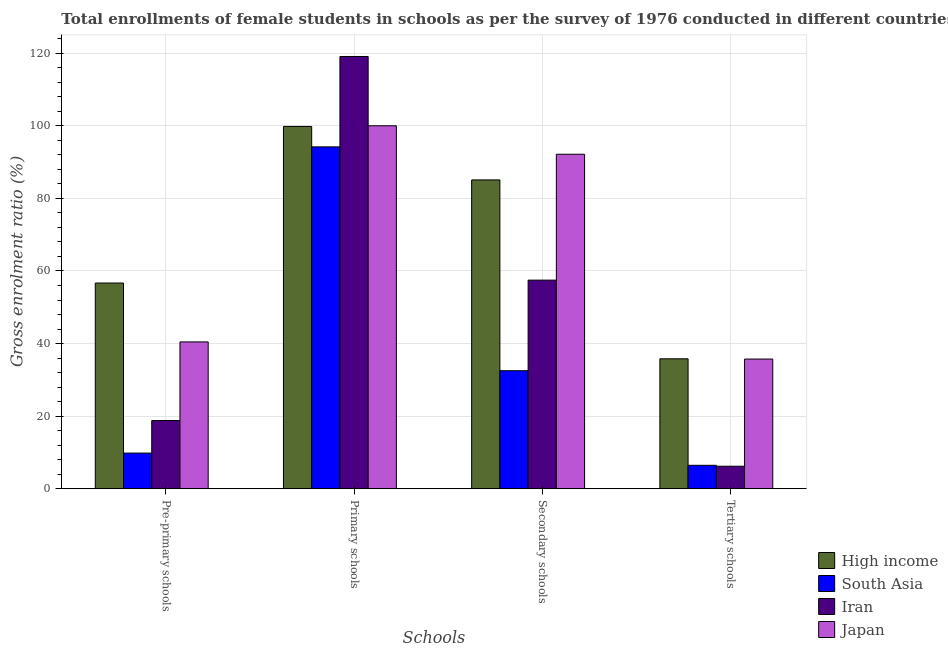Are the number of bars on each tick of the X-axis equal?
Provide a short and direct response. Yes. What is the label of the 2nd group of bars from the left?
Ensure brevity in your answer.  Primary schools. What is the gross enrolment ratio(female) in pre-primary schools in High income?
Keep it short and to the point. 56.68. Across all countries, what is the maximum gross enrolment ratio(female) in pre-primary schools?
Give a very brief answer. 56.68. Across all countries, what is the minimum gross enrolment ratio(female) in pre-primary schools?
Your answer should be compact. 9.81. In which country was the gross enrolment ratio(female) in tertiary schools maximum?
Your answer should be compact. High income. In which country was the gross enrolment ratio(female) in tertiary schools minimum?
Keep it short and to the point. Iran. What is the total gross enrolment ratio(female) in primary schools in the graph?
Make the answer very short. 413.2. What is the difference between the gross enrolment ratio(female) in tertiary schools in High income and that in Japan?
Provide a short and direct response. 0.07. What is the difference between the gross enrolment ratio(female) in primary schools in High income and the gross enrolment ratio(female) in pre-primary schools in Iran?
Provide a short and direct response. 81.07. What is the average gross enrolment ratio(female) in pre-primary schools per country?
Keep it short and to the point. 31.43. What is the difference between the gross enrolment ratio(female) in secondary schools and gross enrolment ratio(female) in tertiary schools in High income?
Ensure brevity in your answer.  49.3. What is the ratio of the gross enrolment ratio(female) in pre-primary schools in South Asia to that in Iran?
Offer a terse response. 0.52. Is the gross enrolment ratio(female) in secondary schools in High income less than that in Japan?
Your response must be concise. Yes. Is the difference between the gross enrolment ratio(female) in pre-primary schools in South Asia and Iran greater than the difference between the gross enrolment ratio(female) in tertiary schools in South Asia and Iran?
Offer a terse response. No. What is the difference between the highest and the second highest gross enrolment ratio(female) in secondary schools?
Your answer should be very brief. 7.07. What is the difference between the highest and the lowest gross enrolment ratio(female) in pre-primary schools?
Ensure brevity in your answer.  46.87. What does the 3rd bar from the right in Secondary schools represents?
Your response must be concise. South Asia. Are all the bars in the graph horizontal?
Offer a terse response. No. What is the difference between two consecutive major ticks on the Y-axis?
Keep it short and to the point. 20. Does the graph contain grids?
Offer a very short reply. Yes. How many legend labels are there?
Offer a terse response. 4. How are the legend labels stacked?
Provide a succinct answer. Vertical. What is the title of the graph?
Offer a very short reply. Total enrollments of female students in schools as per the survey of 1976 conducted in different countries. Does "Tuvalu" appear as one of the legend labels in the graph?
Give a very brief answer. No. What is the label or title of the X-axis?
Offer a terse response. Schools. What is the label or title of the Y-axis?
Your answer should be compact. Gross enrolment ratio (%). What is the Gross enrolment ratio (%) in High income in Pre-primary schools?
Make the answer very short. 56.68. What is the Gross enrolment ratio (%) in South Asia in Pre-primary schools?
Provide a succinct answer. 9.81. What is the Gross enrolment ratio (%) of Iran in Pre-primary schools?
Your answer should be very brief. 18.78. What is the Gross enrolment ratio (%) of Japan in Pre-primary schools?
Offer a terse response. 40.45. What is the Gross enrolment ratio (%) of High income in Primary schools?
Provide a succinct answer. 99.84. What is the Gross enrolment ratio (%) of South Asia in Primary schools?
Provide a short and direct response. 94.21. What is the Gross enrolment ratio (%) in Iran in Primary schools?
Give a very brief answer. 119.12. What is the Gross enrolment ratio (%) of Japan in Primary schools?
Make the answer very short. 100.02. What is the Gross enrolment ratio (%) of High income in Secondary schools?
Ensure brevity in your answer.  85.1. What is the Gross enrolment ratio (%) in South Asia in Secondary schools?
Provide a short and direct response. 32.51. What is the Gross enrolment ratio (%) in Iran in Secondary schools?
Your answer should be compact. 57.48. What is the Gross enrolment ratio (%) of Japan in Secondary schools?
Keep it short and to the point. 92.18. What is the Gross enrolment ratio (%) in High income in Tertiary schools?
Your answer should be compact. 35.8. What is the Gross enrolment ratio (%) of South Asia in Tertiary schools?
Provide a succinct answer. 6.44. What is the Gross enrolment ratio (%) in Iran in Tertiary schools?
Your response must be concise. 6.19. What is the Gross enrolment ratio (%) in Japan in Tertiary schools?
Your answer should be compact. 35.73. Across all Schools, what is the maximum Gross enrolment ratio (%) of High income?
Keep it short and to the point. 99.84. Across all Schools, what is the maximum Gross enrolment ratio (%) of South Asia?
Your answer should be compact. 94.21. Across all Schools, what is the maximum Gross enrolment ratio (%) of Iran?
Your response must be concise. 119.12. Across all Schools, what is the maximum Gross enrolment ratio (%) in Japan?
Offer a very short reply. 100.02. Across all Schools, what is the minimum Gross enrolment ratio (%) in High income?
Provide a succinct answer. 35.8. Across all Schools, what is the minimum Gross enrolment ratio (%) in South Asia?
Your response must be concise. 6.44. Across all Schools, what is the minimum Gross enrolment ratio (%) of Iran?
Your answer should be very brief. 6.19. Across all Schools, what is the minimum Gross enrolment ratio (%) of Japan?
Offer a very short reply. 35.73. What is the total Gross enrolment ratio (%) of High income in the graph?
Your answer should be compact. 277.42. What is the total Gross enrolment ratio (%) in South Asia in the graph?
Make the answer very short. 142.98. What is the total Gross enrolment ratio (%) in Iran in the graph?
Keep it short and to the point. 201.56. What is the total Gross enrolment ratio (%) of Japan in the graph?
Offer a very short reply. 268.38. What is the difference between the Gross enrolment ratio (%) in High income in Pre-primary schools and that in Primary schools?
Give a very brief answer. -43.16. What is the difference between the Gross enrolment ratio (%) in South Asia in Pre-primary schools and that in Primary schools?
Your answer should be compact. -84.4. What is the difference between the Gross enrolment ratio (%) in Iran in Pre-primary schools and that in Primary schools?
Ensure brevity in your answer.  -100.35. What is the difference between the Gross enrolment ratio (%) in Japan in Pre-primary schools and that in Primary schools?
Ensure brevity in your answer.  -59.57. What is the difference between the Gross enrolment ratio (%) in High income in Pre-primary schools and that in Secondary schools?
Provide a short and direct response. -28.42. What is the difference between the Gross enrolment ratio (%) in South Asia in Pre-primary schools and that in Secondary schools?
Provide a succinct answer. -22.7. What is the difference between the Gross enrolment ratio (%) of Iran in Pre-primary schools and that in Secondary schools?
Keep it short and to the point. -38.7. What is the difference between the Gross enrolment ratio (%) of Japan in Pre-primary schools and that in Secondary schools?
Your answer should be very brief. -51.72. What is the difference between the Gross enrolment ratio (%) of High income in Pre-primary schools and that in Tertiary schools?
Your answer should be compact. 20.89. What is the difference between the Gross enrolment ratio (%) in South Asia in Pre-primary schools and that in Tertiary schools?
Offer a very short reply. 3.37. What is the difference between the Gross enrolment ratio (%) in Iran in Pre-primary schools and that in Tertiary schools?
Give a very brief answer. 12.59. What is the difference between the Gross enrolment ratio (%) of Japan in Pre-primary schools and that in Tertiary schools?
Make the answer very short. 4.72. What is the difference between the Gross enrolment ratio (%) in High income in Primary schools and that in Secondary schools?
Offer a very short reply. 14.74. What is the difference between the Gross enrolment ratio (%) in South Asia in Primary schools and that in Secondary schools?
Keep it short and to the point. 61.7. What is the difference between the Gross enrolment ratio (%) of Iran in Primary schools and that in Secondary schools?
Provide a short and direct response. 61.64. What is the difference between the Gross enrolment ratio (%) of Japan in Primary schools and that in Secondary schools?
Provide a short and direct response. 7.85. What is the difference between the Gross enrolment ratio (%) of High income in Primary schools and that in Tertiary schools?
Make the answer very short. 64.05. What is the difference between the Gross enrolment ratio (%) in South Asia in Primary schools and that in Tertiary schools?
Keep it short and to the point. 87.77. What is the difference between the Gross enrolment ratio (%) of Iran in Primary schools and that in Tertiary schools?
Your response must be concise. 112.94. What is the difference between the Gross enrolment ratio (%) of Japan in Primary schools and that in Tertiary schools?
Your answer should be very brief. 64.3. What is the difference between the Gross enrolment ratio (%) in High income in Secondary schools and that in Tertiary schools?
Provide a short and direct response. 49.3. What is the difference between the Gross enrolment ratio (%) in South Asia in Secondary schools and that in Tertiary schools?
Your answer should be very brief. 26.07. What is the difference between the Gross enrolment ratio (%) in Iran in Secondary schools and that in Tertiary schools?
Ensure brevity in your answer.  51.29. What is the difference between the Gross enrolment ratio (%) in Japan in Secondary schools and that in Tertiary schools?
Offer a very short reply. 56.45. What is the difference between the Gross enrolment ratio (%) of High income in Pre-primary schools and the Gross enrolment ratio (%) of South Asia in Primary schools?
Your answer should be very brief. -37.53. What is the difference between the Gross enrolment ratio (%) of High income in Pre-primary schools and the Gross enrolment ratio (%) of Iran in Primary schools?
Your answer should be compact. -62.44. What is the difference between the Gross enrolment ratio (%) of High income in Pre-primary schools and the Gross enrolment ratio (%) of Japan in Primary schools?
Provide a succinct answer. -43.34. What is the difference between the Gross enrolment ratio (%) of South Asia in Pre-primary schools and the Gross enrolment ratio (%) of Iran in Primary schools?
Your answer should be compact. -109.31. What is the difference between the Gross enrolment ratio (%) in South Asia in Pre-primary schools and the Gross enrolment ratio (%) in Japan in Primary schools?
Make the answer very short. -90.21. What is the difference between the Gross enrolment ratio (%) in Iran in Pre-primary schools and the Gross enrolment ratio (%) in Japan in Primary schools?
Your response must be concise. -81.25. What is the difference between the Gross enrolment ratio (%) of High income in Pre-primary schools and the Gross enrolment ratio (%) of South Asia in Secondary schools?
Keep it short and to the point. 24.17. What is the difference between the Gross enrolment ratio (%) in High income in Pre-primary schools and the Gross enrolment ratio (%) in Iran in Secondary schools?
Ensure brevity in your answer.  -0.79. What is the difference between the Gross enrolment ratio (%) in High income in Pre-primary schools and the Gross enrolment ratio (%) in Japan in Secondary schools?
Provide a short and direct response. -35.49. What is the difference between the Gross enrolment ratio (%) of South Asia in Pre-primary schools and the Gross enrolment ratio (%) of Iran in Secondary schools?
Your response must be concise. -47.67. What is the difference between the Gross enrolment ratio (%) in South Asia in Pre-primary schools and the Gross enrolment ratio (%) in Japan in Secondary schools?
Ensure brevity in your answer.  -82.36. What is the difference between the Gross enrolment ratio (%) of Iran in Pre-primary schools and the Gross enrolment ratio (%) of Japan in Secondary schools?
Make the answer very short. -73.4. What is the difference between the Gross enrolment ratio (%) of High income in Pre-primary schools and the Gross enrolment ratio (%) of South Asia in Tertiary schools?
Your response must be concise. 50.24. What is the difference between the Gross enrolment ratio (%) of High income in Pre-primary schools and the Gross enrolment ratio (%) of Iran in Tertiary schools?
Give a very brief answer. 50.5. What is the difference between the Gross enrolment ratio (%) of High income in Pre-primary schools and the Gross enrolment ratio (%) of Japan in Tertiary schools?
Make the answer very short. 20.96. What is the difference between the Gross enrolment ratio (%) in South Asia in Pre-primary schools and the Gross enrolment ratio (%) in Iran in Tertiary schools?
Keep it short and to the point. 3.62. What is the difference between the Gross enrolment ratio (%) in South Asia in Pre-primary schools and the Gross enrolment ratio (%) in Japan in Tertiary schools?
Your response must be concise. -25.92. What is the difference between the Gross enrolment ratio (%) in Iran in Pre-primary schools and the Gross enrolment ratio (%) in Japan in Tertiary schools?
Offer a terse response. -16.95. What is the difference between the Gross enrolment ratio (%) of High income in Primary schools and the Gross enrolment ratio (%) of South Asia in Secondary schools?
Make the answer very short. 67.33. What is the difference between the Gross enrolment ratio (%) in High income in Primary schools and the Gross enrolment ratio (%) in Iran in Secondary schools?
Your response must be concise. 42.37. What is the difference between the Gross enrolment ratio (%) in High income in Primary schools and the Gross enrolment ratio (%) in Japan in Secondary schools?
Offer a terse response. 7.67. What is the difference between the Gross enrolment ratio (%) in South Asia in Primary schools and the Gross enrolment ratio (%) in Iran in Secondary schools?
Your answer should be very brief. 36.73. What is the difference between the Gross enrolment ratio (%) in South Asia in Primary schools and the Gross enrolment ratio (%) in Japan in Secondary schools?
Ensure brevity in your answer.  2.04. What is the difference between the Gross enrolment ratio (%) of Iran in Primary schools and the Gross enrolment ratio (%) of Japan in Secondary schools?
Your answer should be very brief. 26.95. What is the difference between the Gross enrolment ratio (%) of High income in Primary schools and the Gross enrolment ratio (%) of South Asia in Tertiary schools?
Ensure brevity in your answer.  93.4. What is the difference between the Gross enrolment ratio (%) of High income in Primary schools and the Gross enrolment ratio (%) of Iran in Tertiary schools?
Give a very brief answer. 93.66. What is the difference between the Gross enrolment ratio (%) in High income in Primary schools and the Gross enrolment ratio (%) in Japan in Tertiary schools?
Offer a terse response. 64.11. What is the difference between the Gross enrolment ratio (%) of South Asia in Primary schools and the Gross enrolment ratio (%) of Iran in Tertiary schools?
Provide a succinct answer. 88.02. What is the difference between the Gross enrolment ratio (%) of South Asia in Primary schools and the Gross enrolment ratio (%) of Japan in Tertiary schools?
Provide a succinct answer. 58.48. What is the difference between the Gross enrolment ratio (%) of Iran in Primary schools and the Gross enrolment ratio (%) of Japan in Tertiary schools?
Make the answer very short. 83.39. What is the difference between the Gross enrolment ratio (%) of High income in Secondary schools and the Gross enrolment ratio (%) of South Asia in Tertiary schools?
Give a very brief answer. 78.66. What is the difference between the Gross enrolment ratio (%) of High income in Secondary schools and the Gross enrolment ratio (%) of Iran in Tertiary schools?
Ensure brevity in your answer.  78.91. What is the difference between the Gross enrolment ratio (%) of High income in Secondary schools and the Gross enrolment ratio (%) of Japan in Tertiary schools?
Provide a succinct answer. 49.37. What is the difference between the Gross enrolment ratio (%) of South Asia in Secondary schools and the Gross enrolment ratio (%) of Iran in Tertiary schools?
Your response must be concise. 26.33. What is the difference between the Gross enrolment ratio (%) of South Asia in Secondary schools and the Gross enrolment ratio (%) of Japan in Tertiary schools?
Your answer should be very brief. -3.21. What is the difference between the Gross enrolment ratio (%) in Iran in Secondary schools and the Gross enrolment ratio (%) in Japan in Tertiary schools?
Ensure brevity in your answer.  21.75. What is the average Gross enrolment ratio (%) of High income per Schools?
Keep it short and to the point. 69.36. What is the average Gross enrolment ratio (%) in South Asia per Schools?
Give a very brief answer. 35.74. What is the average Gross enrolment ratio (%) of Iran per Schools?
Offer a very short reply. 50.39. What is the average Gross enrolment ratio (%) in Japan per Schools?
Provide a succinct answer. 67.09. What is the difference between the Gross enrolment ratio (%) of High income and Gross enrolment ratio (%) of South Asia in Pre-primary schools?
Your answer should be compact. 46.87. What is the difference between the Gross enrolment ratio (%) of High income and Gross enrolment ratio (%) of Iran in Pre-primary schools?
Keep it short and to the point. 37.91. What is the difference between the Gross enrolment ratio (%) in High income and Gross enrolment ratio (%) in Japan in Pre-primary schools?
Your response must be concise. 16.23. What is the difference between the Gross enrolment ratio (%) in South Asia and Gross enrolment ratio (%) in Iran in Pre-primary schools?
Provide a short and direct response. -8.96. What is the difference between the Gross enrolment ratio (%) of South Asia and Gross enrolment ratio (%) of Japan in Pre-primary schools?
Your response must be concise. -30.64. What is the difference between the Gross enrolment ratio (%) of Iran and Gross enrolment ratio (%) of Japan in Pre-primary schools?
Provide a succinct answer. -21.68. What is the difference between the Gross enrolment ratio (%) of High income and Gross enrolment ratio (%) of South Asia in Primary schools?
Give a very brief answer. 5.63. What is the difference between the Gross enrolment ratio (%) in High income and Gross enrolment ratio (%) in Iran in Primary schools?
Your answer should be very brief. -19.28. What is the difference between the Gross enrolment ratio (%) of High income and Gross enrolment ratio (%) of Japan in Primary schools?
Provide a succinct answer. -0.18. What is the difference between the Gross enrolment ratio (%) of South Asia and Gross enrolment ratio (%) of Iran in Primary schools?
Your answer should be compact. -24.91. What is the difference between the Gross enrolment ratio (%) in South Asia and Gross enrolment ratio (%) in Japan in Primary schools?
Provide a short and direct response. -5.81. What is the difference between the Gross enrolment ratio (%) in Iran and Gross enrolment ratio (%) in Japan in Primary schools?
Keep it short and to the point. 19.1. What is the difference between the Gross enrolment ratio (%) of High income and Gross enrolment ratio (%) of South Asia in Secondary schools?
Provide a short and direct response. 52.59. What is the difference between the Gross enrolment ratio (%) in High income and Gross enrolment ratio (%) in Iran in Secondary schools?
Keep it short and to the point. 27.62. What is the difference between the Gross enrolment ratio (%) of High income and Gross enrolment ratio (%) of Japan in Secondary schools?
Your answer should be compact. -7.07. What is the difference between the Gross enrolment ratio (%) in South Asia and Gross enrolment ratio (%) in Iran in Secondary schools?
Make the answer very short. -24.96. What is the difference between the Gross enrolment ratio (%) in South Asia and Gross enrolment ratio (%) in Japan in Secondary schools?
Offer a terse response. -59.66. What is the difference between the Gross enrolment ratio (%) in Iran and Gross enrolment ratio (%) in Japan in Secondary schools?
Your response must be concise. -34.7. What is the difference between the Gross enrolment ratio (%) of High income and Gross enrolment ratio (%) of South Asia in Tertiary schools?
Your answer should be very brief. 29.35. What is the difference between the Gross enrolment ratio (%) of High income and Gross enrolment ratio (%) of Iran in Tertiary schools?
Make the answer very short. 29.61. What is the difference between the Gross enrolment ratio (%) of High income and Gross enrolment ratio (%) of Japan in Tertiary schools?
Provide a succinct answer. 0.07. What is the difference between the Gross enrolment ratio (%) in South Asia and Gross enrolment ratio (%) in Iran in Tertiary schools?
Keep it short and to the point. 0.26. What is the difference between the Gross enrolment ratio (%) of South Asia and Gross enrolment ratio (%) of Japan in Tertiary schools?
Your answer should be very brief. -29.28. What is the difference between the Gross enrolment ratio (%) of Iran and Gross enrolment ratio (%) of Japan in Tertiary schools?
Your answer should be very brief. -29.54. What is the ratio of the Gross enrolment ratio (%) in High income in Pre-primary schools to that in Primary schools?
Give a very brief answer. 0.57. What is the ratio of the Gross enrolment ratio (%) in South Asia in Pre-primary schools to that in Primary schools?
Keep it short and to the point. 0.1. What is the ratio of the Gross enrolment ratio (%) in Iran in Pre-primary schools to that in Primary schools?
Offer a terse response. 0.16. What is the ratio of the Gross enrolment ratio (%) in Japan in Pre-primary schools to that in Primary schools?
Make the answer very short. 0.4. What is the ratio of the Gross enrolment ratio (%) of High income in Pre-primary schools to that in Secondary schools?
Provide a succinct answer. 0.67. What is the ratio of the Gross enrolment ratio (%) of South Asia in Pre-primary schools to that in Secondary schools?
Ensure brevity in your answer.  0.3. What is the ratio of the Gross enrolment ratio (%) in Iran in Pre-primary schools to that in Secondary schools?
Keep it short and to the point. 0.33. What is the ratio of the Gross enrolment ratio (%) in Japan in Pre-primary schools to that in Secondary schools?
Keep it short and to the point. 0.44. What is the ratio of the Gross enrolment ratio (%) of High income in Pre-primary schools to that in Tertiary schools?
Make the answer very short. 1.58. What is the ratio of the Gross enrolment ratio (%) in South Asia in Pre-primary schools to that in Tertiary schools?
Your response must be concise. 1.52. What is the ratio of the Gross enrolment ratio (%) of Iran in Pre-primary schools to that in Tertiary schools?
Your response must be concise. 3.03. What is the ratio of the Gross enrolment ratio (%) in Japan in Pre-primary schools to that in Tertiary schools?
Provide a succinct answer. 1.13. What is the ratio of the Gross enrolment ratio (%) in High income in Primary schools to that in Secondary schools?
Provide a succinct answer. 1.17. What is the ratio of the Gross enrolment ratio (%) in South Asia in Primary schools to that in Secondary schools?
Ensure brevity in your answer.  2.9. What is the ratio of the Gross enrolment ratio (%) of Iran in Primary schools to that in Secondary schools?
Provide a succinct answer. 2.07. What is the ratio of the Gross enrolment ratio (%) of Japan in Primary schools to that in Secondary schools?
Your response must be concise. 1.09. What is the ratio of the Gross enrolment ratio (%) in High income in Primary schools to that in Tertiary schools?
Give a very brief answer. 2.79. What is the ratio of the Gross enrolment ratio (%) in South Asia in Primary schools to that in Tertiary schools?
Offer a very short reply. 14.62. What is the ratio of the Gross enrolment ratio (%) of Iran in Primary schools to that in Tertiary schools?
Give a very brief answer. 19.25. What is the ratio of the Gross enrolment ratio (%) of Japan in Primary schools to that in Tertiary schools?
Keep it short and to the point. 2.8. What is the ratio of the Gross enrolment ratio (%) in High income in Secondary schools to that in Tertiary schools?
Make the answer very short. 2.38. What is the ratio of the Gross enrolment ratio (%) in South Asia in Secondary schools to that in Tertiary schools?
Make the answer very short. 5.05. What is the ratio of the Gross enrolment ratio (%) of Iran in Secondary schools to that in Tertiary schools?
Offer a very short reply. 9.29. What is the ratio of the Gross enrolment ratio (%) in Japan in Secondary schools to that in Tertiary schools?
Ensure brevity in your answer.  2.58. What is the difference between the highest and the second highest Gross enrolment ratio (%) of High income?
Offer a very short reply. 14.74. What is the difference between the highest and the second highest Gross enrolment ratio (%) of South Asia?
Your answer should be very brief. 61.7. What is the difference between the highest and the second highest Gross enrolment ratio (%) in Iran?
Your answer should be compact. 61.64. What is the difference between the highest and the second highest Gross enrolment ratio (%) of Japan?
Provide a short and direct response. 7.85. What is the difference between the highest and the lowest Gross enrolment ratio (%) in High income?
Give a very brief answer. 64.05. What is the difference between the highest and the lowest Gross enrolment ratio (%) of South Asia?
Your answer should be compact. 87.77. What is the difference between the highest and the lowest Gross enrolment ratio (%) of Iran?
Keep it short and to the point. 112.94. What is the difference between the highest and the lowest Gross enrolment ratio (%) of Japan?
Offer a very short reply. 64.3. 